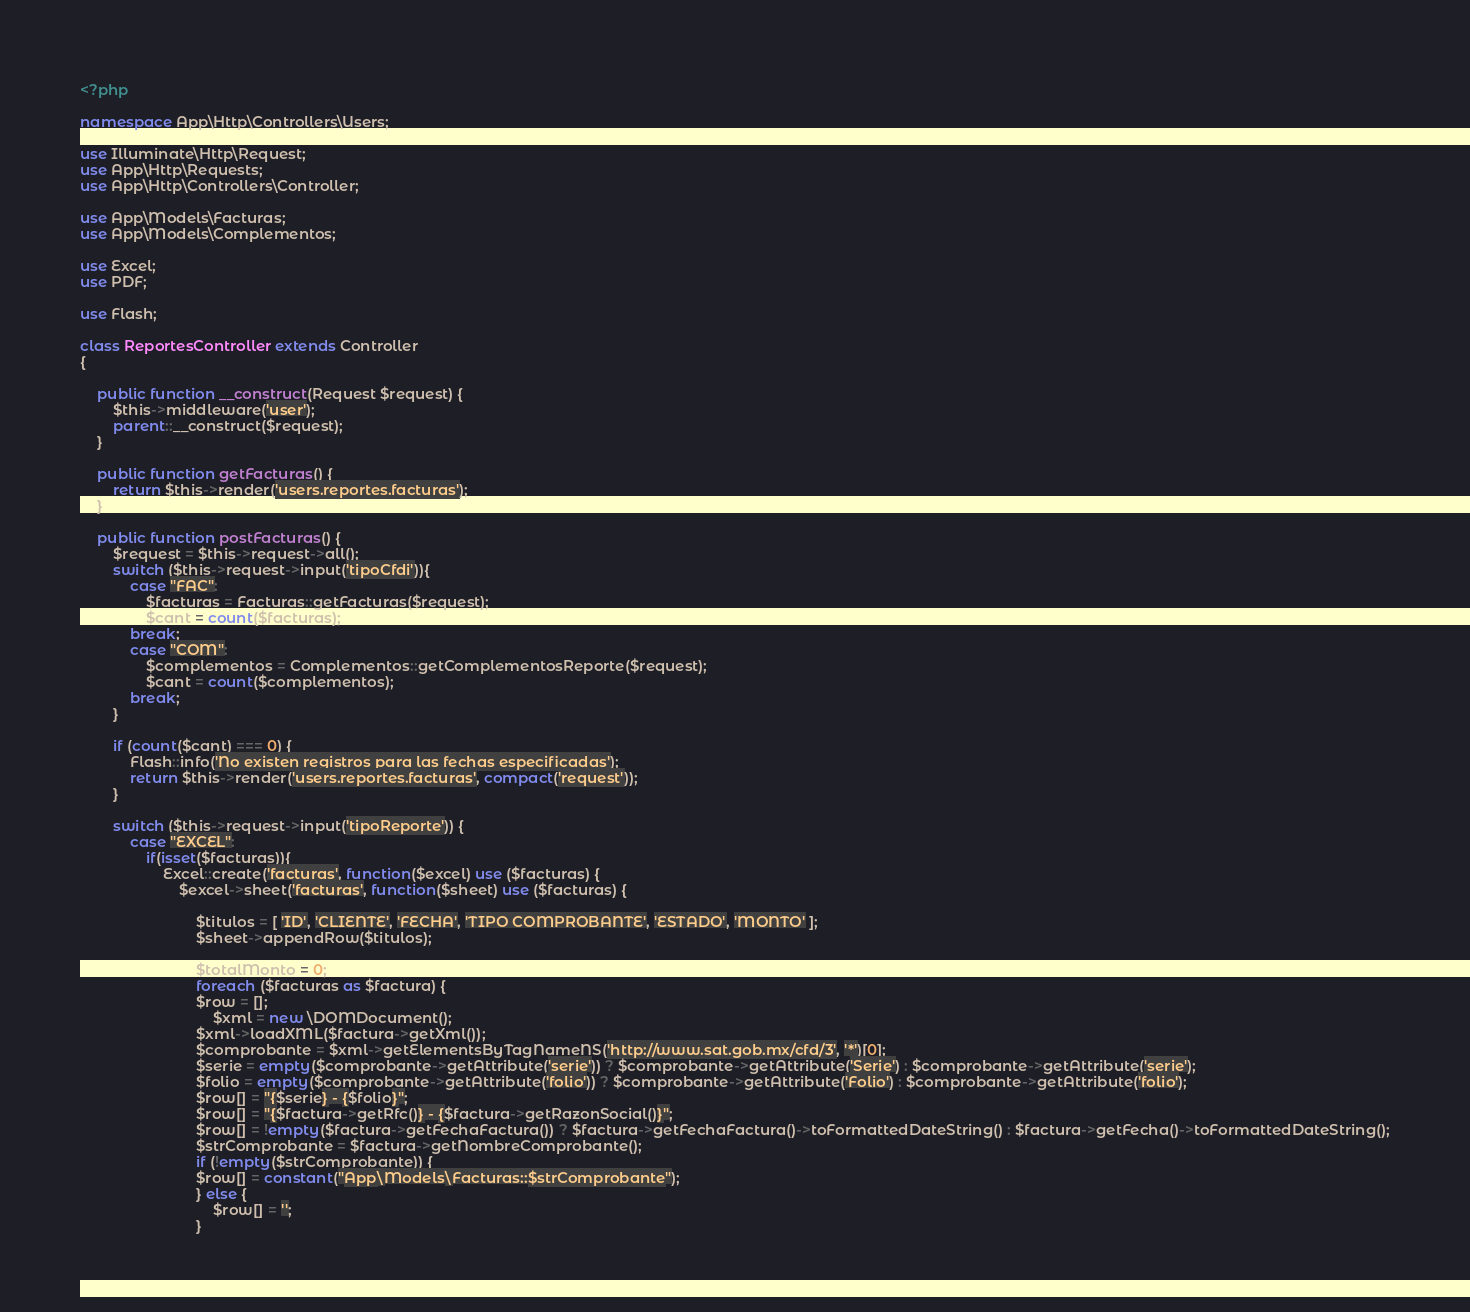<code> <loc_0><loc_0><loc_500><loc_500><_PHP_><?php

namespace App\Http\Controllers\Users;

use Illuminate\Http\Request;
use App\Http\Requests;
use App\Http\Controllers\Controller;

use App\Models\Facturas;
use App\Models\Complementos;

use Excel;
use PDF;

use Flash;

class ReportesController extends Controller
{

    public function __construct(Request $request) {
        $this->middleware('user');
        parent::__construct($request);
    }

    public function getFacturas() {
        return $this->render('users.reportes.facturas');
    }

    public function postFacturas() {
        $request = $this->request->all();
        switch ($this->request->input('tipoCfdi')){
            case "FAC":
                $facturas = Facturas::getFacturas($request);
                $cant = count($facturas);
            break;
            case "COM":
                $complementos = Complementos::getComplementosReporte($request);
                $cant = count($complementos);
            break;
        }

        if (count($cant) === 0) {
            Flash::info('No existen registros para las fechas especificadas');
            return $this->render('users.reportes.facturas', compact('request'));
        }

        switch ($this->request->input('tipoReporte')) {
            case "EXCEL":
                if(isset($facturas)){
                    Excel::create('facturas', function($excel) use ($facturas) {
                        $excel->sheet('facturas', function($sheet) use ($facturas) {

                            $titulos = [ 'ID', 'CLIENTE', 'FECHA', 'TIPO COMPROBANTE', 'ESTADO', 'MONTO' ];
                            $sheet->appendRow($titulos);

                            $totalMonto = 0;
                            foreach ($facturas as $factura) {
                            $row = [];
                                $xml = new \DOMDocument();
                            $xml->loadXML($factura->getXml());
                            $comprobante = $xml->getElementsByTagNameNS('http://www.sat.gob.mx/cfd/3', '*')[0];
                            $serie = empty($comprobante->getAttribute('serie')) ? $comprobante->getAttribute('Serie') : $comprobante->getAttribute('serie');
                            $folio = empty($comprobante->getAttribute('folio')) ? $comprobante->getAttribute('Folio') : $comprobante->getAttribute('folio');
                            $row[] = "{$serie} - {$folio}";
                            $row[] = "{$factura->getRfc()} - {$factura->getRazonSocial()}";
                            $row[] = !empty($factura->getFechaFactura()) ? $factura->getFechaFactura()->toFormattedDateString() : $factura->getFecha()->toFormattedDateString();
                            $strComprobante = $factura->getNombreComprobante();
                            if (!empty($strComprobante)) {
                            $row[] = constant("App\Models\Facturas::$strComprobante");
                            } else {
                                $row[] = '';
                            }</code> 